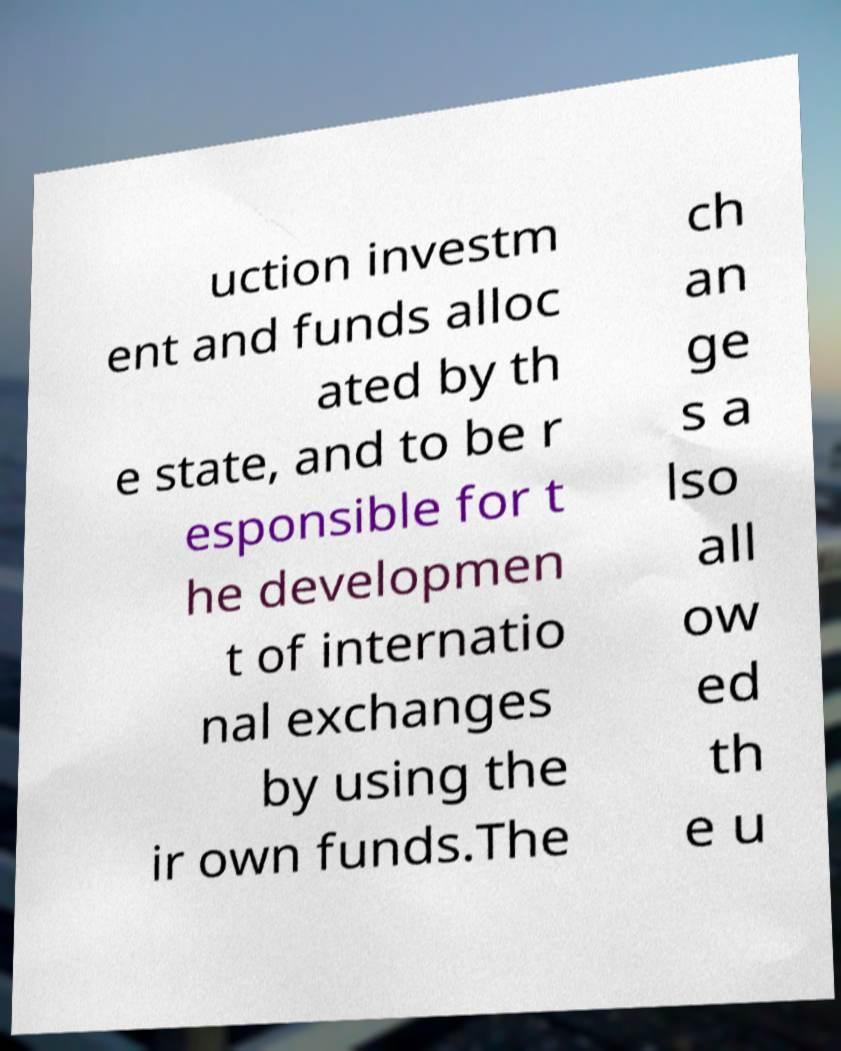I need the written content from this picture converted into text. Can you do that? uction investm ent and funds alloc ated by th e state, and to be r esponsible for t he developmen t of internatio nal exchanges by using the ir own funds.The ch an ge s a lso all ow ed th e u 